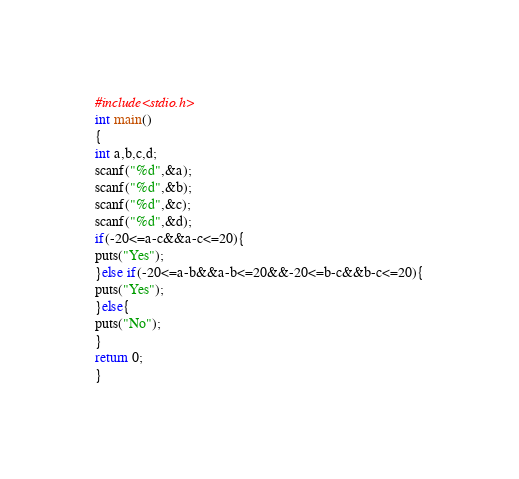Convert code to text. <code><loc_0><loc_0><loc_500><loc_500><_C_>#include<stdio.h>
int main()
{
int a,b,c,d;
scanf("%d",&a);
scanf("%d",&b);
scanf("%d",&c);
scanf("%d",&d);
if(-20<=a-c&&a-c<=20){
puts("Yes");
}else if(-20<=a-b&&a-b<=20&&-20<=b-c&&b-c<=20){
puts("Yes");
}else{
puts("No");
}
return 0;
}</code> 